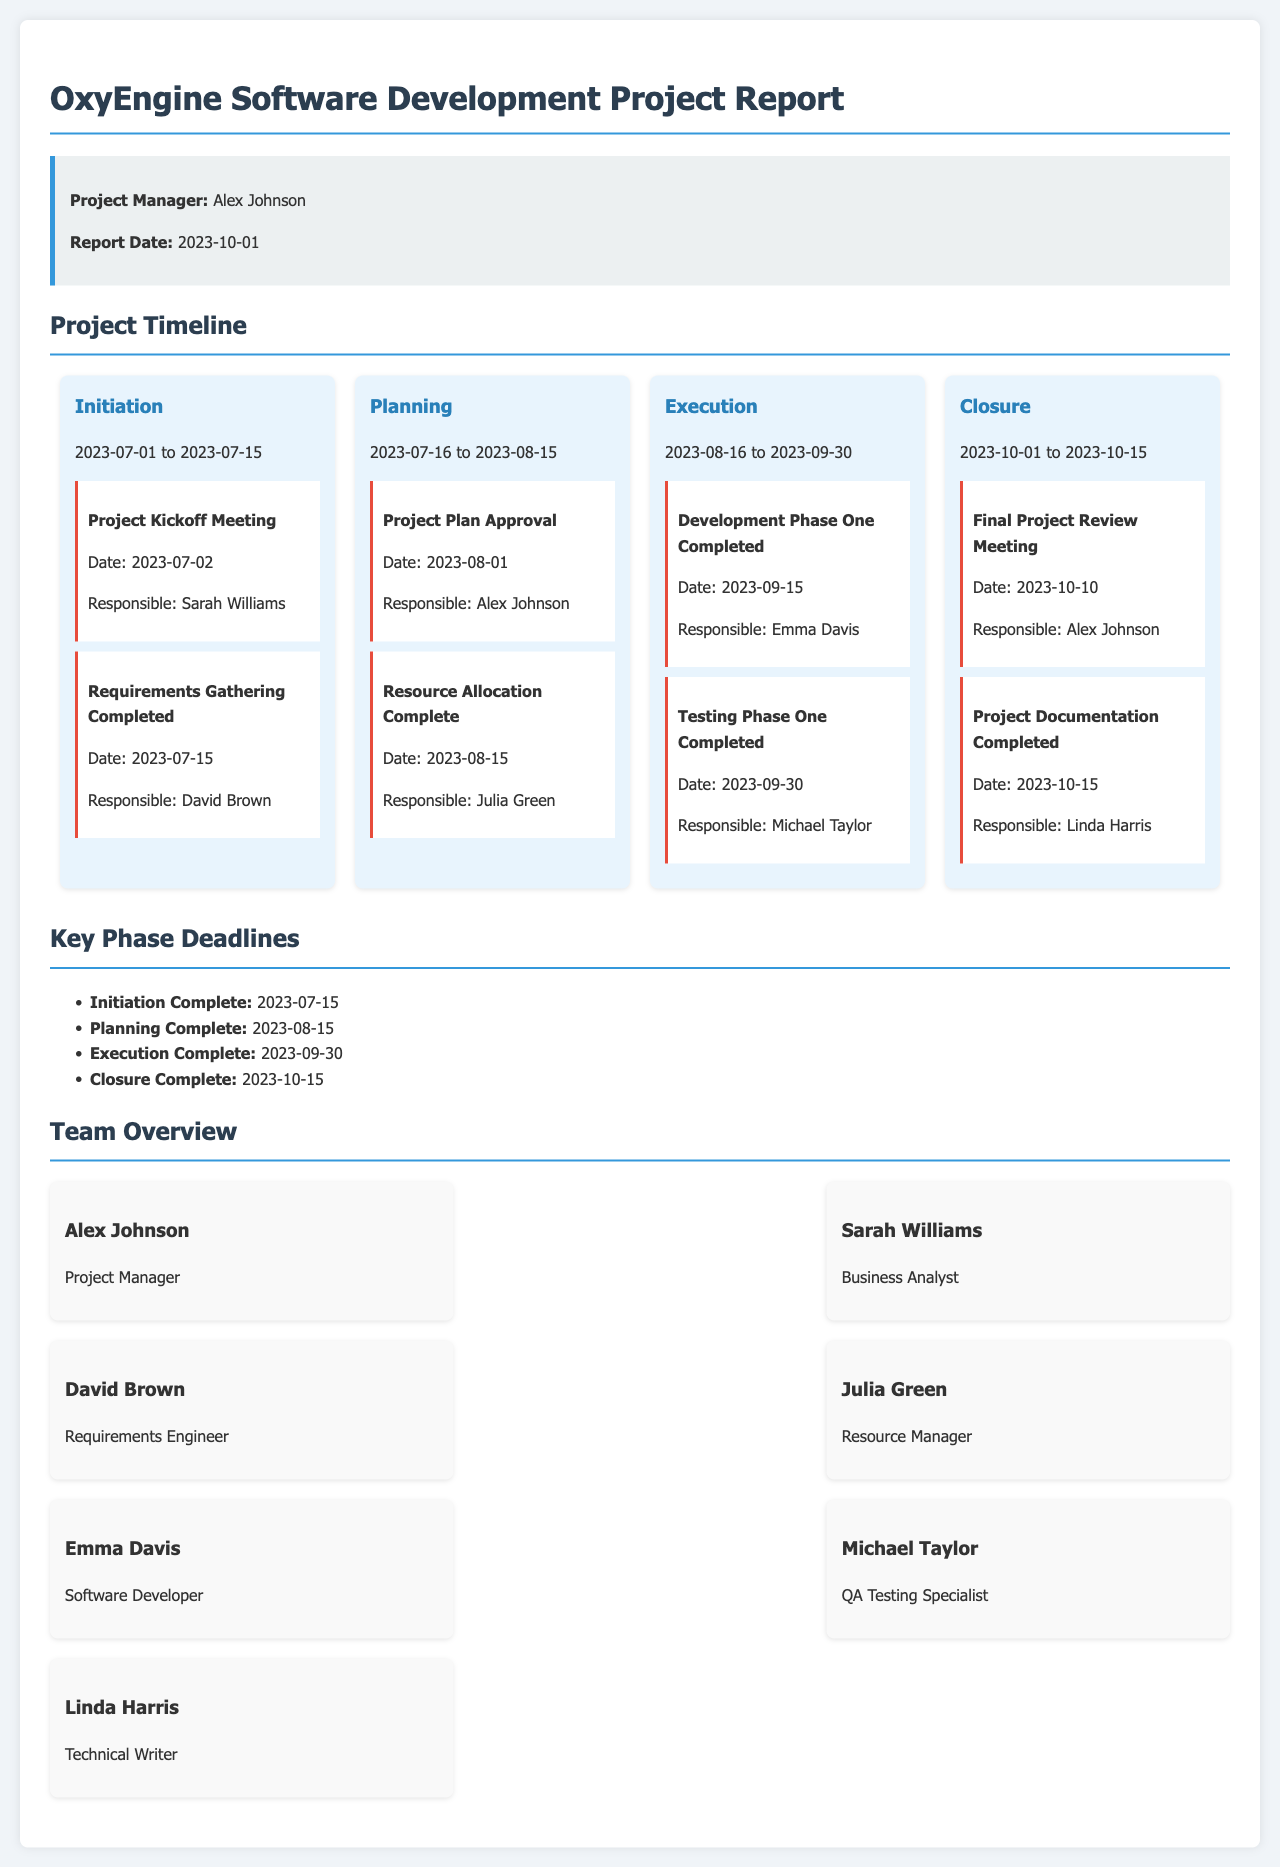What is the name of the project manager? The project manager is clearly mentioned in the project info section of the report, which states the project manager's name is Alex Johnson.
Answer: Alex Johnson What is the date of the project kickoff meeting? The date of the project kickoff meeting is provided under the milestones in the Initiation phase, which states it is on 2023-07-02.
Answer: 2023-07-02 When is the project plan approval date? The date for project plan approval is listed in the Planning phase as 2023-08-01.
Answer: 2023-08-01 Who is responsible for the Testing Phase One completion? The responsible team member for Testing Phase One completion is mentioned in the Execution phase as Michael Taylor.
Answer: Michael Taylor What is the deadline for project documentation completion? The deadline for project documentation is provided in the Closure phase, which states it will be completed by 2023-10-15.
Answer: 2023-10-15 Which team member is a Business Analyst? The report mentions the roles of team members, and Sarah Williams is identified as the Business Analyst.
Answer: Sarah Williams What is the completion date for the Execution phase? The completion date for the Execution phase is stated in the Key Phase Deadlines section as 2023-09-30.
Answer: 2023-09-30 What phase follows the Planning phase? The timeline section of the report outlines the phases of the project, and the phase following Planning is Execution.
Answer: Execution How many phases are outlined in the project timeline? The report lists four distinct phases of the project timeline, which are Initiation, Planning, Execution, and Closure.
Answer: Four 